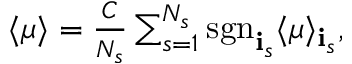Convert formula to latex. <formula><loc_0><loc_0><loc_500><loc_500>\begin{array} { r } { \langle \mu \rangle = \frac { C } { N _ { s } } \sum _ { s = 1 } ^ { N _ { s } } s g n _ { { \mathbf i } _ { s } } \langle \mu \rangle _ { { \mathbf i } _ { s } } , } \end{array}</formula> 